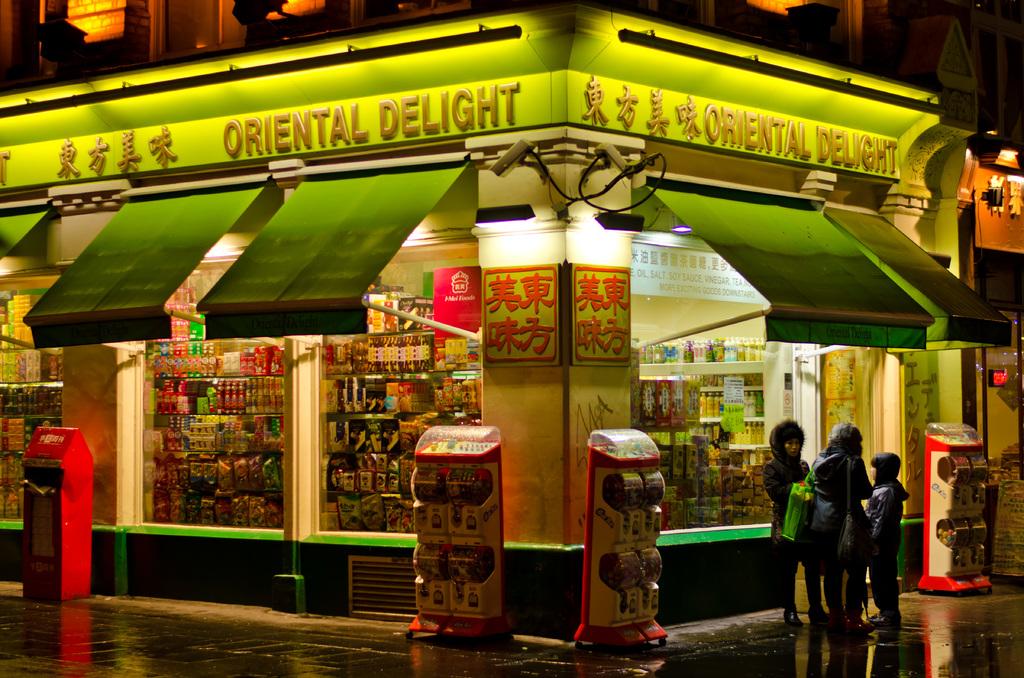What kind of delight is this business?
Provide a short and direct response. Oriental. What is the name of the restaurant?
Offer a very short reply. Oriental delight. 